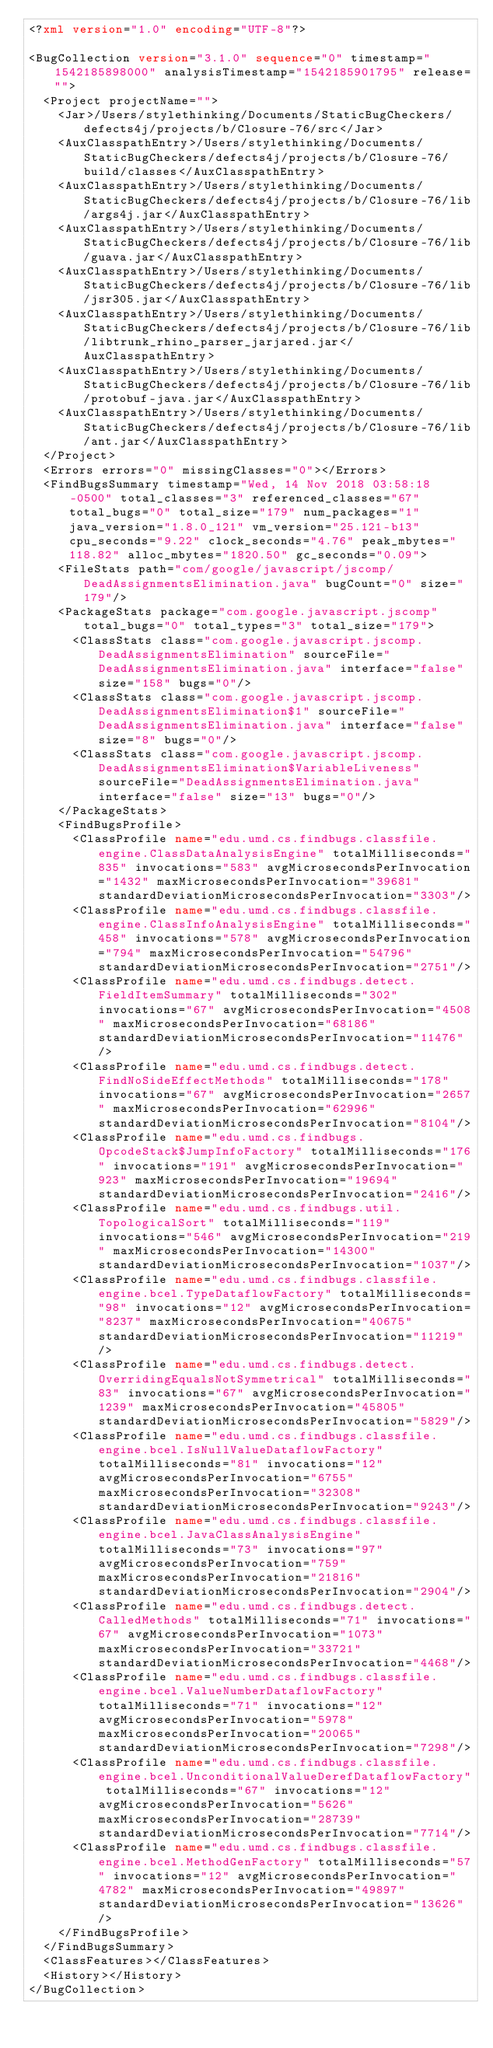<code> <loc_0><loc_0><loc_500><loc_500><_XML_><?xml version="1.0" encoding="UTF-8"?>

<BugCollection version="3.1.0" sequence="0" timestamp="1542185898000" analysisTimestamp="1542185901795" release="">
  <Project projectName="">
    <Jar>/Users/stylethinking/Documents/StaticBugCheckers/defects4j/projects/b/Closure-76/src</Jar>
    <AuxClasspathEntry>/Users/stylethinking/Documents/StaticBugCheckers/defects4j/projects/b/Closure-76/build/classes</AuxClasspathEntry>
    <AuxClasspathEntry>/Users/stylethinking/Documents/StaticBugCheckers/defects4j/projects/b/Closure-76/lib/args4j.jar</AuxClasspathEntry>
    <AuxClasspathEntry>/Users/stylethinking/Documents/StaticBugCheckers/defects4j/projects/b/Closure-76/lib/guava.jar</AuxClasspathEntry>
    <AuxClasspathEntry>/Users/stylethinking/Documents/StaticBugCheckers/defects4j/projects/b/Closure-76/lib/jsr305.jar</AuxClasspathEntry>
    <AuxClasspathEntry>/Users/stylethinking/Documents/StaticBugCheckers/defects4j/projects/b/Closure-76/lib/libtrunk_rhino_parser_jarjared.jar</AuxClasspathEntry>
    <AuxClasspathEntry>/Users/stylethinking/Documents/StaticBugCheckers/defects4j/projects/b/Closure-76/lib/protobuf-java.jar</AuxClasspathEntry>
    <AuxClasspathEntry>/Users/stylethinking/Documents/StaticBugCheckers/defects4j/projects/b/Closure-76/lib/ant.jar</AuxClasspathEntry>
  </Project>
  <Errors errors="0" missingClasses="0"></Errors>
  <FindBugsSummary timestamp="Wed, 14 Nov 2018 03:58:18 -0500" total_classes="3" referenced_classes="67" total_bugs="0" total_size="179" num_packages="1" java_version="1.8.0_121" vm_version="25.121-b13" cpu_seconds="9.22" clock_seconds="4.76" peak_mbytes="118.82" alloc_mbytes="1820.50" gc_seconds="0.09">
    <FileStats path="com/google/javascript/jscomp/DeadAssignmentsElimination.java" bugCount="0" size="179"/>
    <PackageStats package="com.google.javascript.jscomp" total_bugs="0" total_types="3" total_size="179">
      <ClassStats class="com.google.javascript.jscomp.DeadAssignmentsElimination" sourceFile="DeadAssignmentsElimination.java" interface="false" size="158" bugs="0"/>
      <ClassStats class="com.google.javascript.jscomp.DeadAssignmentsElimination$1" sourceFile="DeadAssignmentsElimination.java" interface="false" size="8" bugs="0"/>
      <ClassStats class="com.google.javascript.jscomp.DeadAssignmentsElimination$VariableLiveness" sourceFile="DeadAssignmentsElimination.java" interface="false" size="13" bugs="0"/>
    </PackageStats>
    <FindBugsProfile>
      <ClassProfile name="edu.umd.cs.findbugs.classfile.engine.ClassDataAnalysisEngine" totalMilliseconds="835" invocations="583" avgMicrosecondsPerInvocation="1432" maxMicrosecondsPerInvocation="39681" standardDeviationMicrosecondsPerInvocation="3303"/>
      <ClassProfile name="edu.umd.cs.findbugs.classfile.engine.ClassInfoAnalysisEngine" totalMilliseconds="458" invocations="578" avgMicrosecondsPerInvocation="794" maxMicrosecondsPerInvocation="54796" standardDeviationMicrosecondsPerInvocation="2751"/>
      <ClassProfile name="edu.umd.cs.findbugs.detect.FieldItemSummary" totalMilliseconds="302" invocations="67" avgMicrosecondsPerInvocation="4508" maxMicrosecondsPerInvocation="68186" standardDeviationMicrosecondsPerInvocation="11476"/>
      <ClassProfile name="edu.umd.cs.findbugs.detect.FindNoSideEffectMethods" totalMilliseconds="178" invocations="67" avgMicrosecondsPerInvocation="2657" maxMicrosecondsPerInvocation="62996" standardDeviationMicrosecondsPerInvocation="8104"/>
      <ClassProfile name="edu.umd.cs.findbugs.OpcodeStack$JumpInfoFactory" totalMilliseconds="176" invocations="191" avgMicrosecondsPerInvocation="923" maxMicrosecondsPerInvocation="19694" standardDeviationMicrosecondsPerInvocation="2416"/>
      <ClassProfile name="edu.umd.cs.findbugs.util.TopologicalSort" totalMilliseconds="119" invocations="546" avgMicrosecondsPerInvocation="219" maxMicrosecondsPerInvocation="14300" standardDeviationMicrosecondsPerInvocation="1037"/>
      <ClassProfile name="edu.umd.cs.findbugs.classfile.engine.bcel.TypeDataflowFactory" totalMilliseconds="98" invocations="12" avgMicrosecondsPerInvocation="8237" maxMicrosecondsPerInvocation="40675" standardDeviationMicrosecondsPerInvocation="11219"/>
      <ClassProfile name="edu.umd.cs.findbugs.detect.OverridingEqualsNotSymmetrical" totalMilliseconds="83" invocations="67" avgMicrosecondsPerInvocation="1239" maxMicrosecondsPerInvocation="45805" standardDeviationMicrosecondsPerInvocation="5829"/>
      <ClassProfile name="edu.umd.cs.findbugs.classfile.engine.bcel.IsNullValueDataflowFactory" totalMilliseconds="81" invocations="12" avgMicrosecondsPerInvocation="6755" maxMicrosecondsPerInvocation="32308" standardDeviationMicrosecondsPerInvocation="9243"/>
      <ClassProfile name="edu.umd.cs.findbugs.classfile.engine.bcel.JavaClassAnalysisEngine" totalMilliseconds="73" invocations="97" avgMicrosecondsPerInvocation="759" maxMicrosecondsPerInvocation="21816" standardDeviationMicrosecondsPerInvocation="2904"/>
      <ClassProfile name="edu.umd.cs.findbugs.detect.CalledMethods" totalMilliseconds="71" invocations="67" avgMicrosecondsPerInvocation="1073" maxMicrosecondsPerInvocation="33721" standardDeviationMicrosecondsPerInvocation="4468"/>
      <ClassProfile name="edu.umd.cs.findbugs.classfile.engine.bcel.ValueNumberDataflowFactory" totalMilliseconds="71" invocations="12" avgMicrosecondsPerInvocation="5978" maxMicrosecondsPerInvocation="20065" standardDeviationMicrosecondsPerInvocation="7298"/>
      <ClassProfile name="edu.umd.cs.findbugs.classfile.engine.bcel.UnconditionalValueDerefDataflowFactory" totalMilliseconds="67" invocations="12" avgMicrosecondsPerInvocation="5626" maxMicrosecondsPerInvocation="28739" standardDeviationMicrosecondsPerInvocation="7714"/>
      <ClassProfile name="edu.umd.cs.findbugs.classfile.engine.bcel.MethodGenFactory" totalMilliseconds="57" invocations="12" avgMicrosecondsPerInvocation="4782" maxMicrosecondsPerInvocation="49897" standardDeviationMicrosecondsPerInvocation="13626"/>
    </FindBugsProfile>
  </FindBugsSummary>
  <ClassFeatures></ClassFeatures>
  <History></History>
</BugCollection>
</code> 